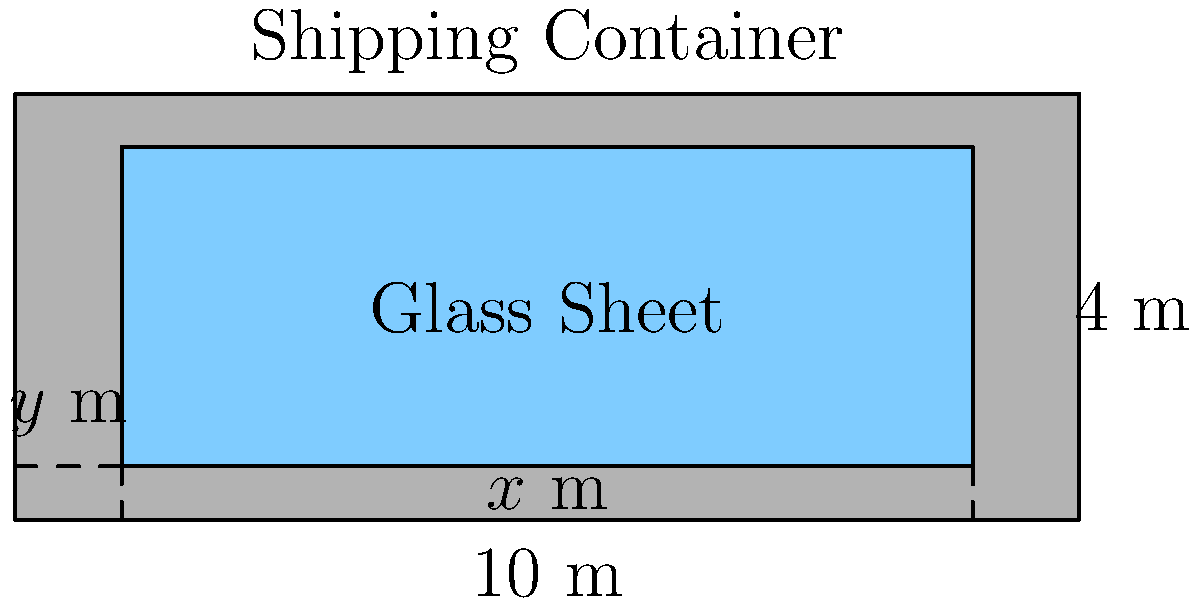As a glass material importer, you're optimizing the size of rectangular glass sheets for shipping containers. The internal dimensions of a standard container are 10 meters long and 4 meters wide. To protect the glass during shipping, you need to leave a buffer of $y$ meters on each side and $x$ meters at each end. If the area of the glass sheet is given by $A = (10-2x)(4-2y)$, what values of $x$ and $y$ will maximize the area of the glass sheet that can be safely shipped? To find the maximum area, we need to follow these steps:

1) The area function is $A = (10-2x)(4-2y)$
   $A = 40 - 20y - 8x + 4xy$

2) To find the maximum, we need to find the partial derivatives with respect to $x$ and $y$ and set them to zero:

   $\frac{\partial A}{\partial x} = -8 + 4y = 0$
   $\frac{\partial A}{\partial y} = -20 + 4x = 0$

3) Solve these equations:
   From $-8 + 4y = 0$, we get $y = 2$
   From $-20 + 4x = 0$, we get $x = 5$

4) To confirm this is a maximum, we can check the second derivatives:
   $\frac{\partial^2 A}{\partial x^2} = 0$
   $\frac{\partial^2 A}{\partial y^2} = 0$
   $\frac{\partial^2 A}{\partial x \partial y} = 4$

   The determinant of the Hessian matrix is negative, confirming a saddle point.

5) However, given the constraints of our problem (x and y must be positive and less than half the container's dimensions), this saddle point is actually our global maximum within the feasible region.

6) Therefore, the optimal buffer sizes are:
   $x = 5$ meters (at each end)
   $y = 2$ meters (on each side)

This will result in a glass sheet that is 0 meters long (10 - 2*5) and 0 meters wide (4 - 2*2), which is not practical.

7) In reality, we need to choose smaller buffer sizes. A common practice in shipping is to use about 10% of the container's dimensions for buffering. So practical values would be:
   $x \approx 0.5$ meters
   $y \approx 0.2$ meters

This would result in a glass sheet that is 9 meters long and 3.6 meters wide, which is much more reasonable for shipping.
Answer: Theoretical maximum: $x = 5$ m, $y = 2$ m. Practical optimum: $x \approx 0.5$ m, $y \approx 0.2$ m. 